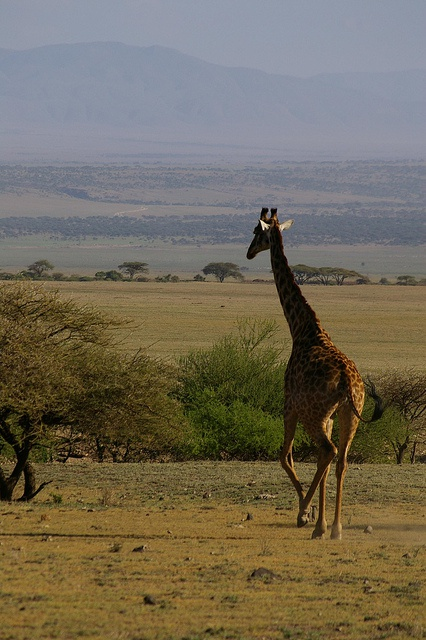Describe the objects in this image and their specific colors. I can see a giraffe in darkgray, black, olive, and maroon tones in this image. 